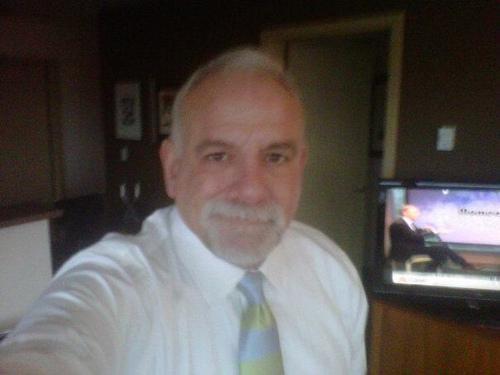How many people are pictured?
Give a very brief answer. 1. 